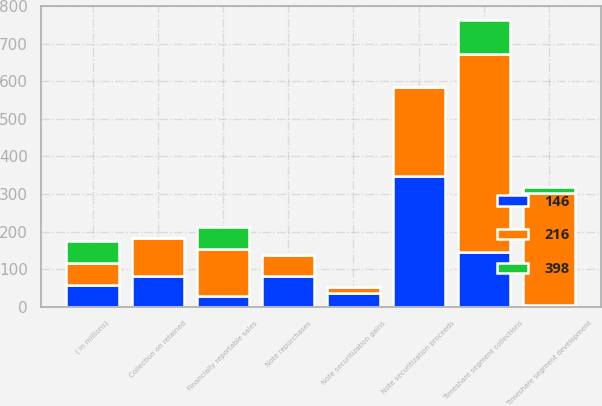Convert chart to OTSL. <chart><loc_0><loc_0><loc_500><loc_500><stacked_bar_chart><ecel><fcel>( in millions)<fcel>Timeshare segment development<fcel>Timeshare segment collections<fcel>Note repurchases<fcel>Financially reportable sales<fcel>Note securitization gains<fcel>Note securitization proceeds<fcel>Collection on retained<nl><fcel>398<fcel>58<fcel>15<fcel>91<fcel>0<fcel>58<fcel>0<fcel>0<fcel>0<nl><fcel>146<fcel>58<fcel>4<fcel>147<fcel>81<fcel>29<fcel>37<fcel>349<fcel>82<nl><fcel>216<fcel>58<fcel>299<fcel>525<fcel>56<fcel>126<fcel>16<fcel>237<fcel>102<nl></chart> 